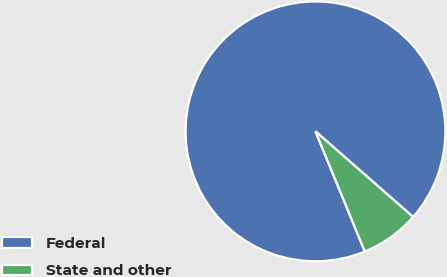Convert chart. <chart><loc_0><loc_0><loc_500><loc_500><pie_chart><fcel>Federal<fcel>State and other<nl><fcel>92.66%<fcel>7.34%<nl></chart> 